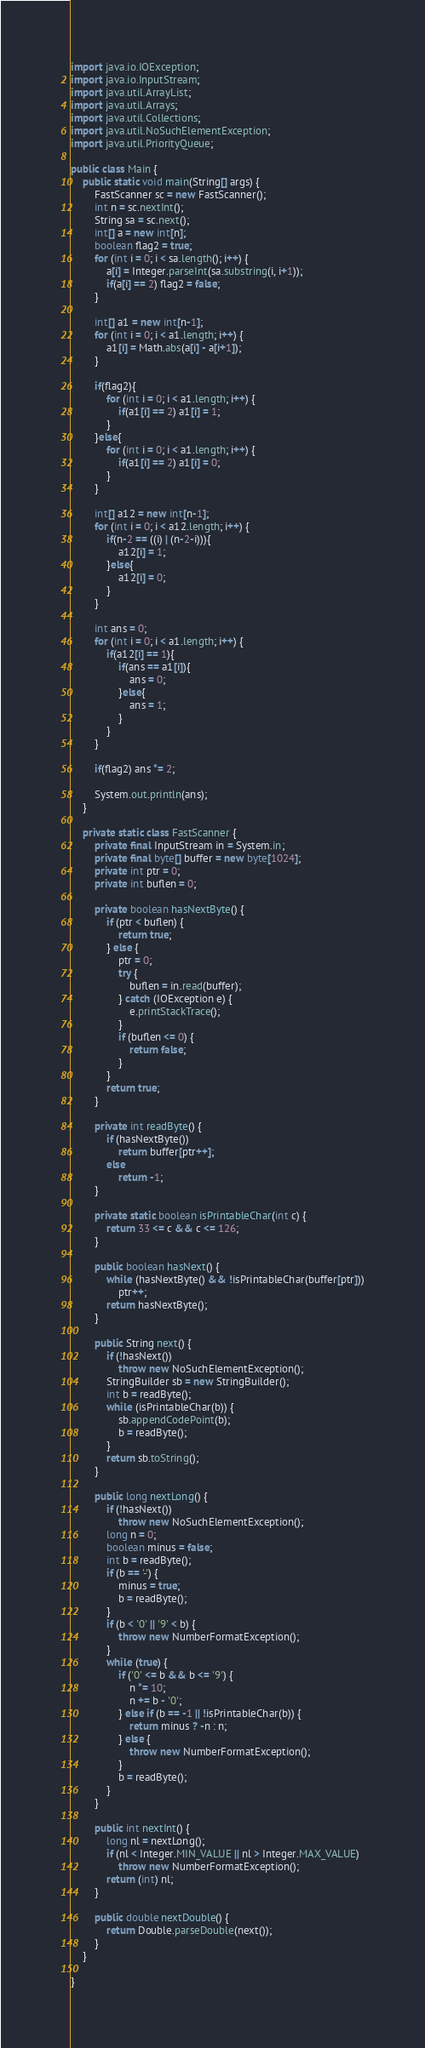Convert code to text. <code><loc_0><loc_0><loc_500><loc_500><_Java_>import java.io.IOException;
import java.io.InputStream;
import java.util.ArrayList;
import java.util.Arrays;
import java.util.Collections;
import java.util.NoSuchElementException;
import java.util.PriorityQueue;

public class Main {
    public static void main(String[] args) {
        FastScanner sc = new FastScanner();
        int n = sc.nextInt();
        String sa = sc.next();
        int[] a = new int[n];
        boolean flag2 = true;
        for (int i = 0; i < sa.length(); i++) {
            a[i] = Integer.parseInt(sa.substring(i, i+1));
            if(a[i] == 2) flag2 = false;
        }

        int[] a1 = new int[n-1];
        for (int i = 0; i < a1.length; i++) {
            a1[i] = Math.abs(a[i] - a[i+1]);
        }

        if(flag2){
            for (int i = 0; i < a1.length; i++) {
                if(a1[i] == 2) a1[i] = 1;
            }
        }else{
            for (int i = 0; i < a1.length; i++) {
                if(a1[i] == 2) a1[i] = 0;
            }
        }

        int[] a12 = new int[n-1];
        for (int i = 0; i < a12.length; i++) {
            if(n-2 == ((i) | (n-2-i))){
                a12[i] = 1;
            }else{
                a12[i] = 0;
            }
        }

        int ans = 0;
        for (int i = 0; i < a1.length; i++) {
            if(a12[i] == 1){
                if(ans == a1[i]){
                    ans = 0;
                }else{
                    ans = 1;
                }
            }
        }

        if(flag2) ans *= 2;

        System.out.println(ans);
    }

    private static class FastScanner {
        private final InputStream in = System.in;
        private final byte[] buffer = new byte[1024];
        private int ptr = 0;
        private int buflen = 0;

        private boolean hasNextByte() {
            if (ptr < buflen) {
                return true;
            } else {
                ptr = 0;
                try {
                    buflen = in.read(buffer);
                } catch (IOException e) {
                    e.printStackTrace();
                }
                if (buflen <= 0) {
                    return false;
                }
            }
            return true;
        }

        private int readByte() {
            if (hasNextByte())
                return buffer[ptr++];
            else
                return -1;
        }

        private static boolean isPrintableChar(int c) {
            return 33 <= c && c <= 126;
        }

        public boolean hasNext() {
            while (hasNextByte() && !isPrintableChar(buffer[ptr]))
                ptr++;
            return hasNextByte();
        }

        public String next() {
            if (!hasNext())
                throw new NoSuchElementException();
            StringBuilder sb = new StringBuilder();
            int b = readByte();
            while (isPrintableChar(b)) {
                sb.appendCodePoint(b);
                b = readByte();
            }
            return sb.toString();
        }

        public long nextLong() {
            if (!hasNext())
                throw new NoSuchElementException();
            long n = 0;
            boolean minus = false;
            int b = readByte();
            if (b == '-') {
                minus = true;
                b = readByte();
            }
            if (b < '0' || '9' < b) {
                throw new NumberFormatException();
            }
            while (true) {
                if ('0' <= b && b <= '9') {
                    n *= 10;
                    n += b - '0';
                } else if (b == -1 || !isPrintableChar(b)) {
                    return minus ? -n : n;
                } else {
                    throw new NumberFormatException();
                }
                b = readByte();
            }
        }

        public int nextInt() {
            long nl = nextLong();
            if (nl < Integer.MIN_VALUE || nl > Integer.MAX_VALUE)
                throw new NumberFormatException();
            return (int) nl;
        }

        public double nextDouble() {
            return Double.parseDouble(next());
        }
    }

}
</code> 